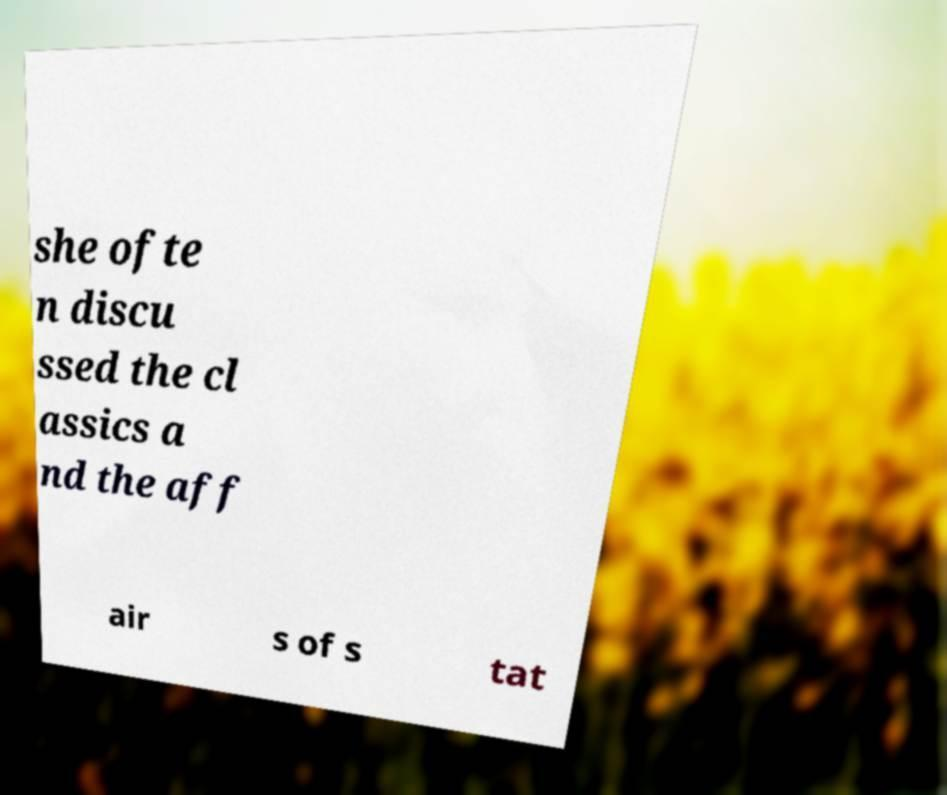There's text embedded in this image that I need extracted. Can you transcribe it verbatim? she ofte n discu ssed the cl assics a nd the aff air s of s tat 